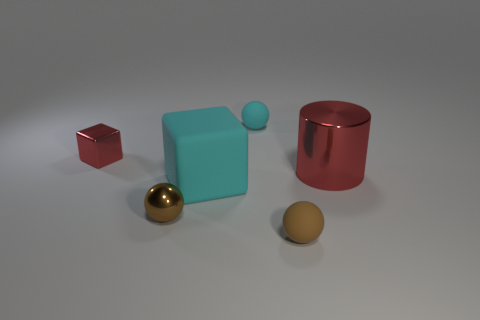What material is the red thing behind the red metallic object that is right of the cube that is in front of the small red cube made of? The red object behind the cylindrical red metallic object, which is to the right of the turquoise cube that's in front of the smaller red cube, appears to be a red-painted metal cylinder, judging by its reflective surface and consistent with the materials seen in other objects within the image. 